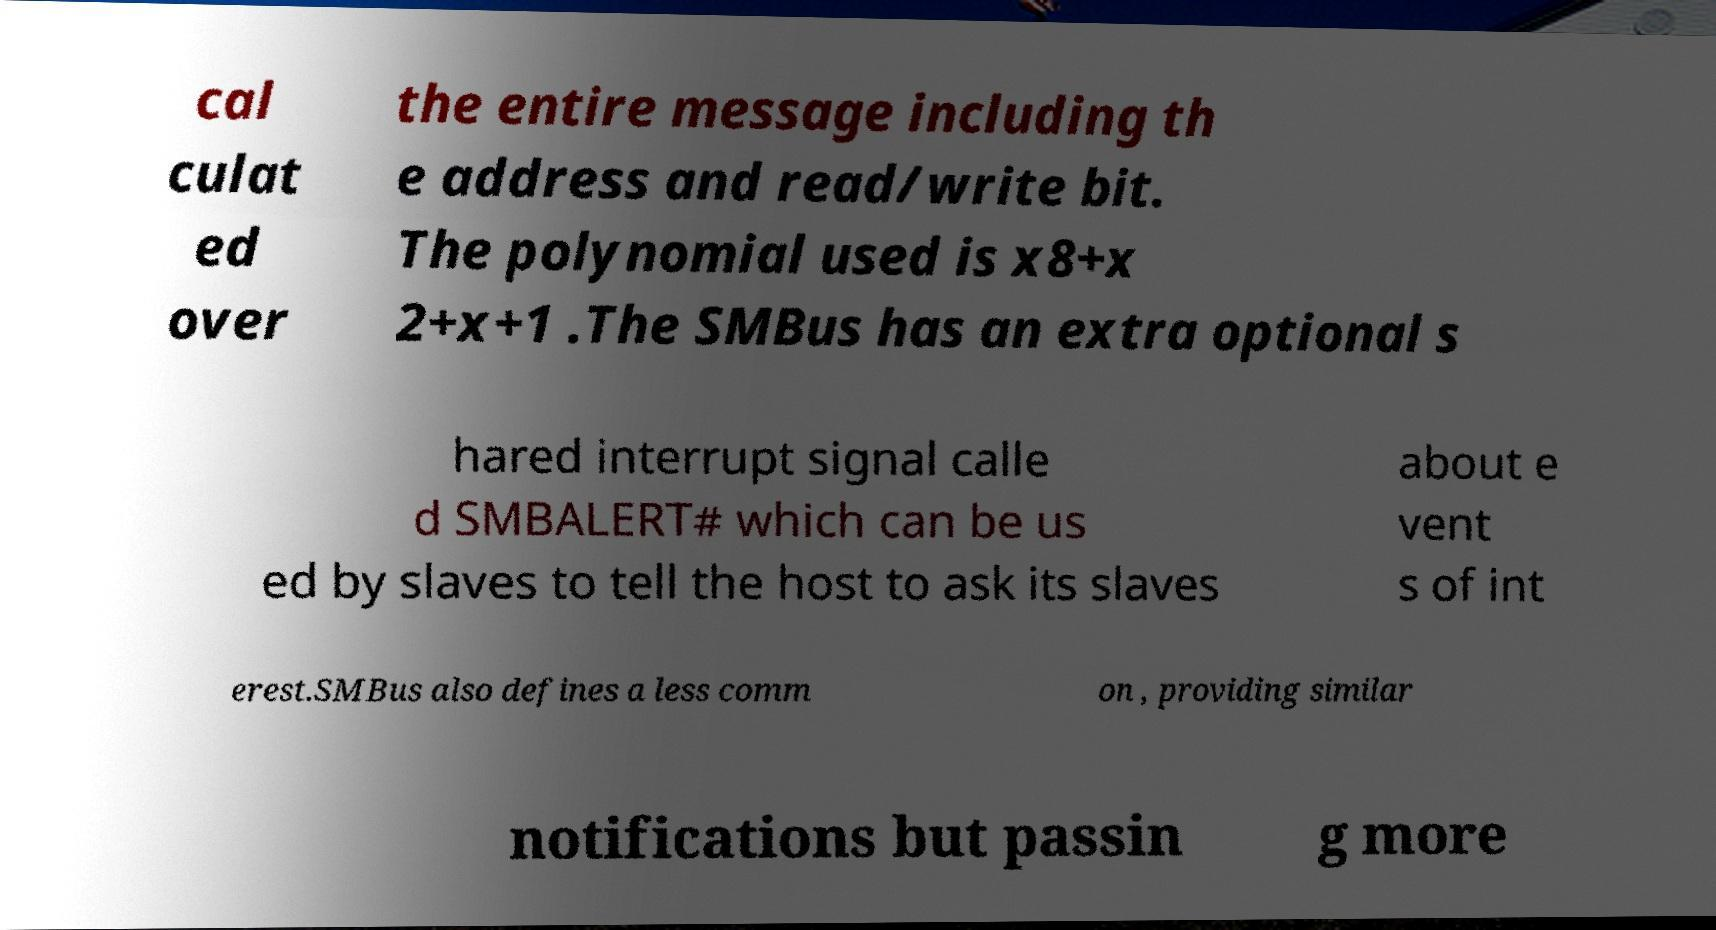Could you assist in decoding the text presented in this image and type it out clearly? cal culat ed over the entire message including th e address and read/write bit. The polynomial used is x8+x 2+x+1 .The SMBus has an extra optional s hared interrupt signal calle d SMBALERT# which can be us ed by slaves to tell the host to ask its slaves about e vent s of int erest.SMBus also defines a less comm on , providing similar notifications but passin g more 